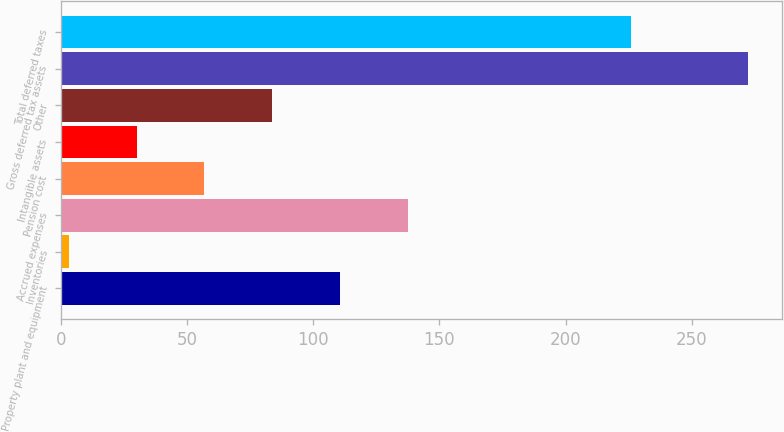<chart> <loc_0><loc_0><loc_500><loc_500><bar_chart><fcel>Property plant and equipment<fcel>Inventories<fcel>Accrued expenses<fcel>Pension cost<fcel>Intangible assets<fcel>Other<fcel>Gross deferred tax assets<fcel>Total deferred taxes<nl><fcel>110.68<fcel>3<fcel>137.6<fcel>56.84<fcel>29.92<fcel>83.76<fcel>272.2<fcel>225.9<nl></chart> 